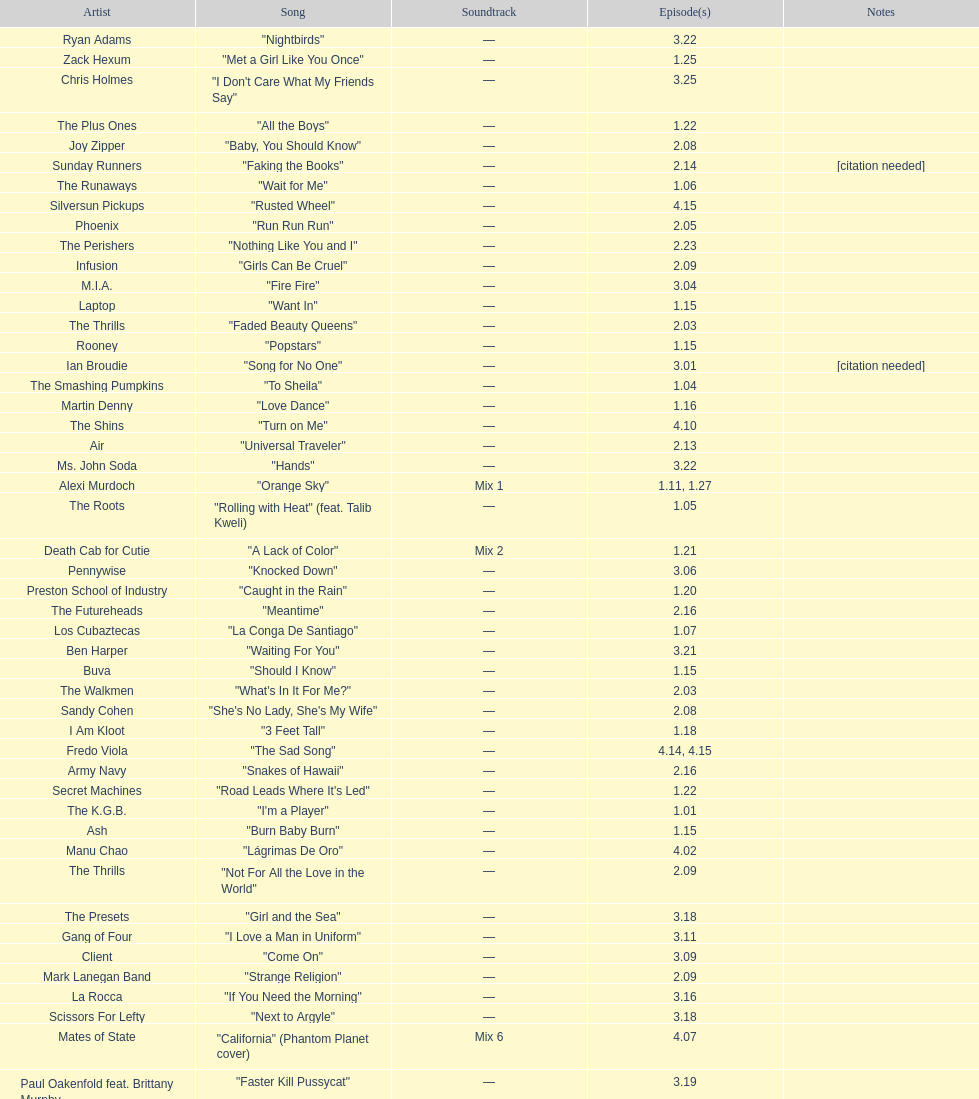What artist has more music appear in the show, daft punk or franz ferdinand? Franz Ferdinand. 